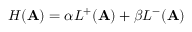Convert formula to latex. <formula><loc_0><loc_0><loc_500><loc_500>H ( A ) = \alpha L ^ { + } ( A ) + \beta L ^ { - } ( A )</formula> 